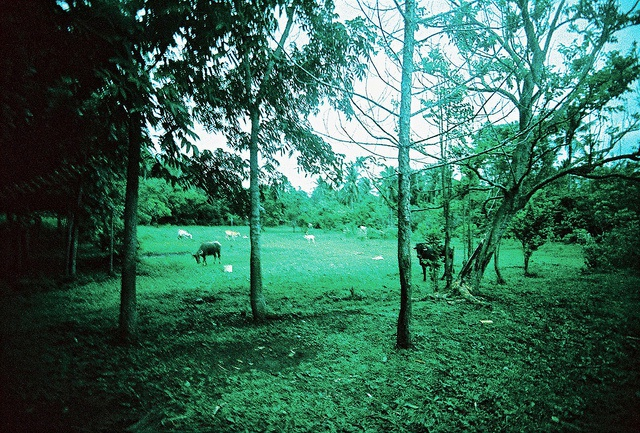Describe the objects in this image and their specific colors. I can see cow in black, darkgreen, teal, and green tones, cow in black, darkgreen, and green tones, and sheep in black, white, lightblue, and turquoise tones in this image. 